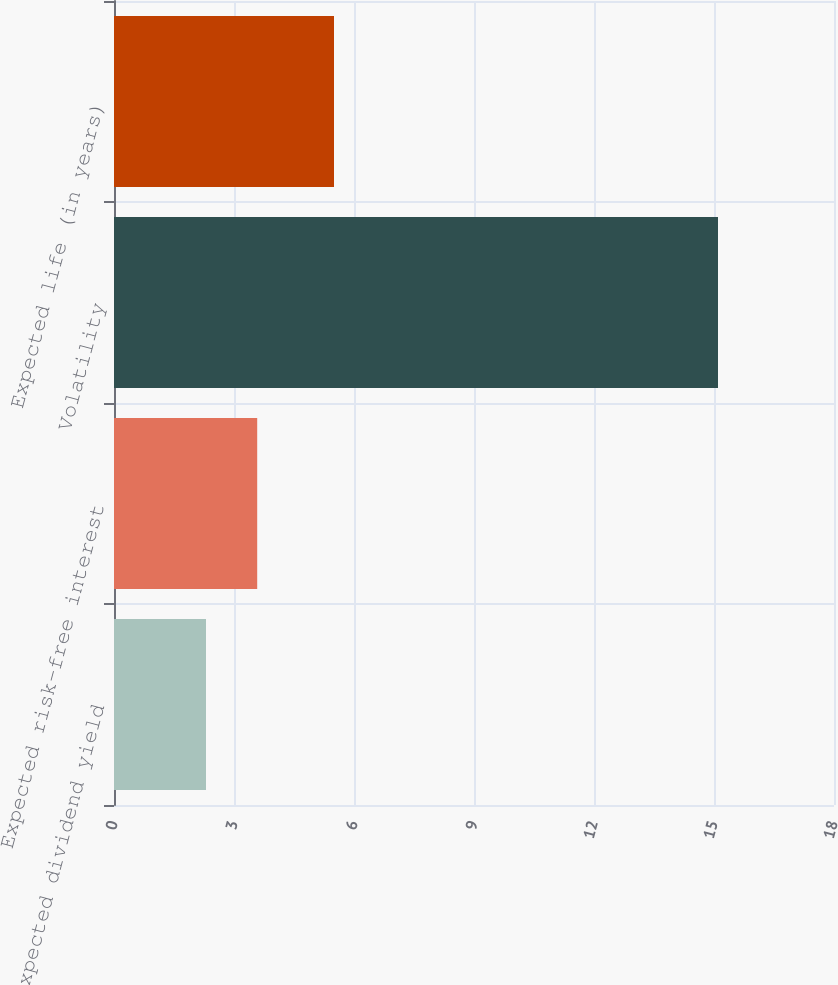<chart> <loc_0><loc_0><loc_500><loc_500><bar_chart><fcel>Expected dividend yield<fcel>Expected risk-free interest<fcel>Volatility<fcel>Expected life (in years)<nl><fcel>2.3<fcel>3.58<fcel>15.1<fcel>5.5<nl></chart> 